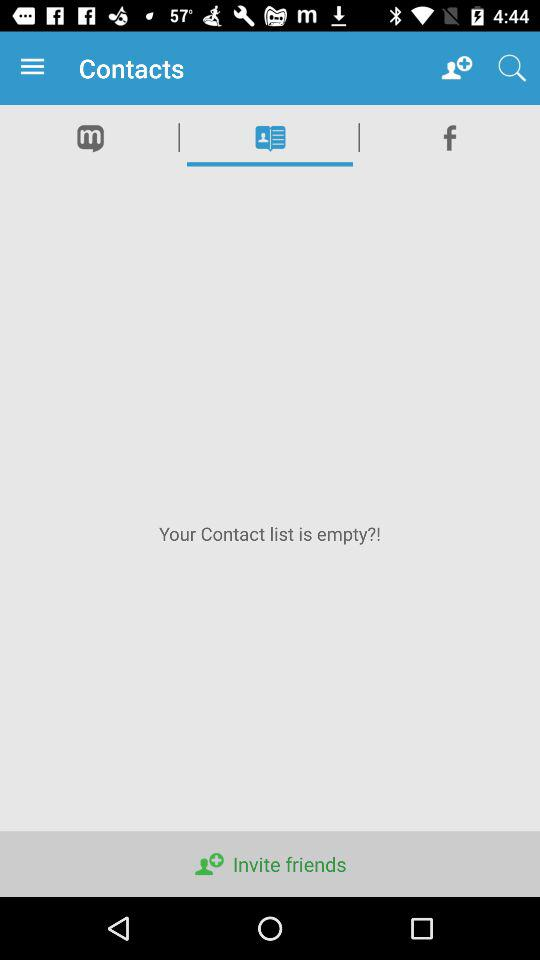Is there any contact listed in the list?
When the provided information is insufficient, respond with <no answer>. <no answer> 